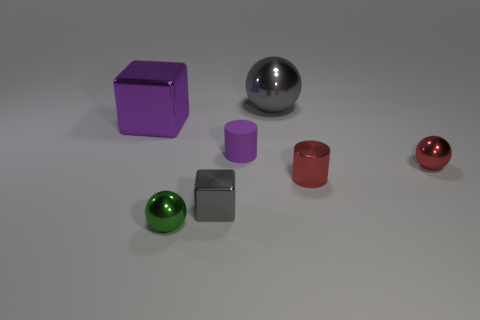Can you classify the objects in the image by shape and color? Certainly! In the image, there are spheres, cubes, and cylinders. The spheres come in green, gray, and red; the cubes appear in purple and gray; and the cylinders are found in purple and red. Each shape has a distinct color, and no color is shared between shapes. 